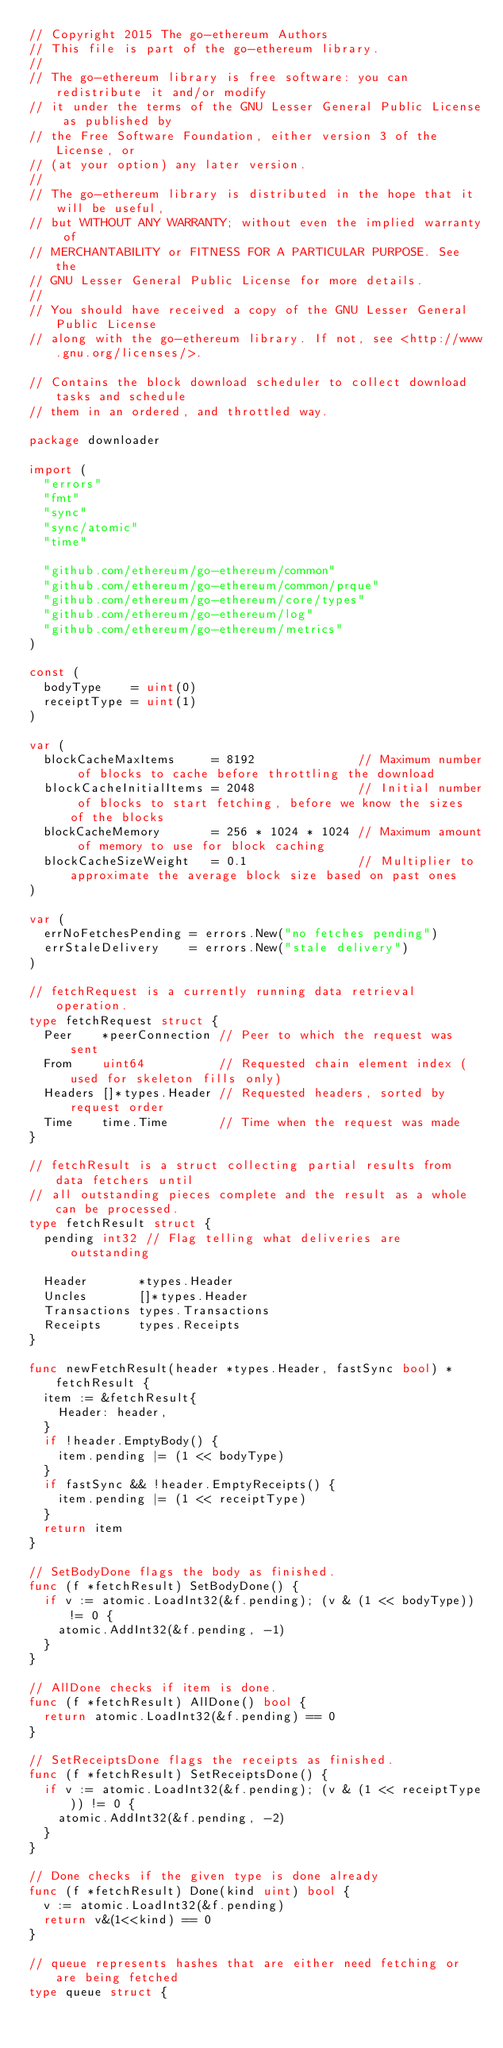Convert code to text. <code><loc_0><loc_0><loc_500><loc_500><_Go_>// Copyright 2015 The go-ethereum Authors
// This file is part of the go-ethereum library.
//
// The go-ethereum library is free software: you can redistribute it and/or modify
// it under the terms of the GNU Lesser General Public License as published by
// the Free Software Foundation, either version 3 of the License, or
// (at your option) any later version.
//
// The go-ethereum library is distributed in the hope that it will be useful,
// but WITHOUT ANY WARRANTY; without even the implied warranty of
// MERCHANTABILITY or FITNESS FOR A PARTICULAR PURPOSE. See the
// GNU Lesser General Public License for more details.
//
// You should have received a copy of the GNU Lesser General Public License
// along with the go-ethereum library. If not, see <http://www.gnu.org/licenses/>.

// Contains the block download scheduler to collect download tasks and schedule
// them in an ordered, and throttled way.

package downloader

import (
	"errors"
	"fmt"
	"sync"
	"sync/atomic"
	"time"

	"github.com/ethereum/go-ethereum/common"
	"github.com/ethereum/go-ethereum/common/prque"
	"github.com/ethereum/go-ethereum/core/types"
	"github.com/ethereum/go-ethereum/log"
	"github.com/ethereum/go-ethereum/metrics"
)

const (
	bodyType    = uint(0)
	receiptType = uint(1)
)

var (
	blockCacheMaxItems     = 8192              // Maximum number of blocks to cache before throttling the download
	blockCacheInitialItems = 2048              // Initial number of blocks to start fetching, before we know the sizes of the blocks
	blockCacheMemory       = 256 * 1024 * 1024 // Maximum amount of memory to use for block caching
	blockCacheSizeWeight   = 0.1               // Multiplier to approximate the average block size based on past ones
)

var (
	errNoFetchesPending = errors.New("no fetches pending")
	errStaleDelivery    = errors.New("stale delivery")
)

// fetchRequest is a currently running data retrieval operation.
type fetchRequest struct {
	Peer    *peerConnection // Peer to which the request was sent
	From    uint64          // Requested chain element index (used for skeleton fills only)
	Headers []*types.Header // Requested headers, sorted by request order
	Time    time.Time       // Time when the request was made
}

// fetchResult is a struct collecting partial results from data fetchers until
// all outstanding pieces complete and the result as a whole can be processed.
type fetchResult struct {
	pending int32 // Flag telling what deliveries are outstanding

	Header       *types.Header
	Uncles       []*types.Header
	Transactions types.Transactions
	Receipts     types.Receipts
}

func newFetchResult(header *types.Header, fastSync bool) *fetchResult {
	item := &fetchResult{
		Header: header,
	}
	if !header.EmptyBody() {
		item.pending |= (1 << bodyType)
	}
	if fastSync && !header.EmptyReceipts() {
		item.pending |= (1 << receiptType)
	}
	return item
}

// SetBodyDone flags the body as finished.
func (f *fetchResult) SetBodyDone() {
	if v := atomic.LoadInt32(&f.pending); (v & (1 << bodyType)) != 0 {
		atomic.AddInt32(&f.pending, -1)
	}
}

// AllDone checks if item is done.
func (f *fetchResult) AllDone() bool {
	return atomic.LoadInt32(&f.pending) == 0
}

// SetReceiptsDone flags the receipts as finished.
func (f *fetchResult) SetReceiptsDone() {
	if v := atomic.LoadInt32(&f.pending); (v & (1 << receiptType)) != 0 {
		atomic.AddInt32(&f.pending, -2)
	}
}

// Done checks if the given type is done already
func (f *fetchResult) Done(kind uint) bool {
	v := atomic.LoadInt32(&f.pending)
	return v&(1<<kind) == 0
}

// queue represents hashes that are either need fetching or are being fetched
type queue struct {</code> 